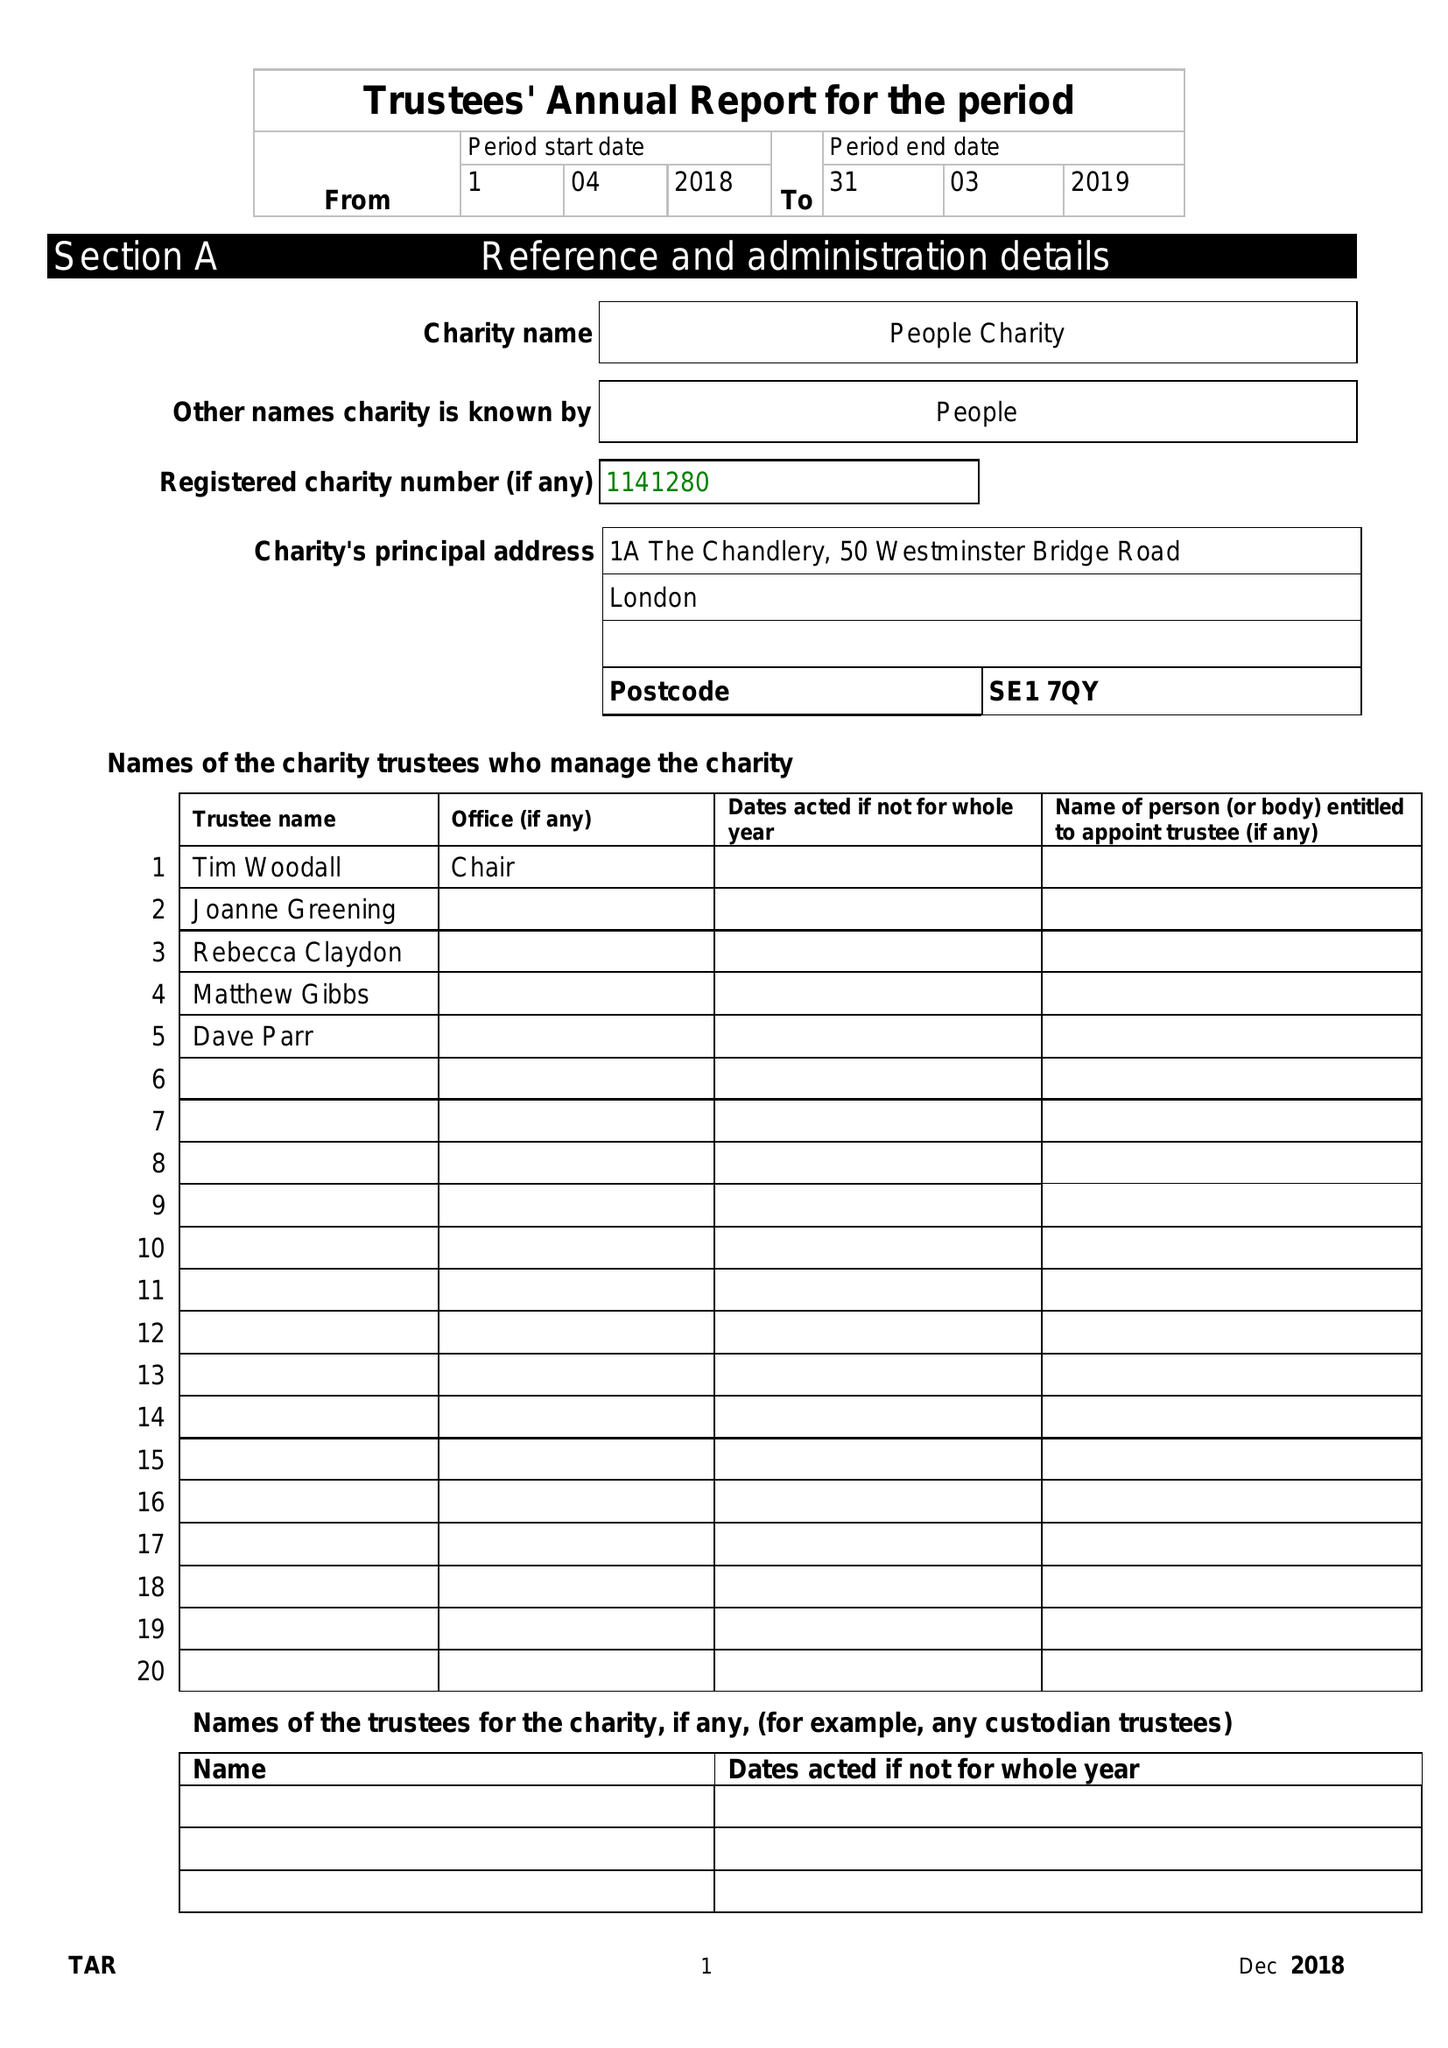What is the value for the report_date?
Answer the question using a single word or phrase. 2018-03-31 